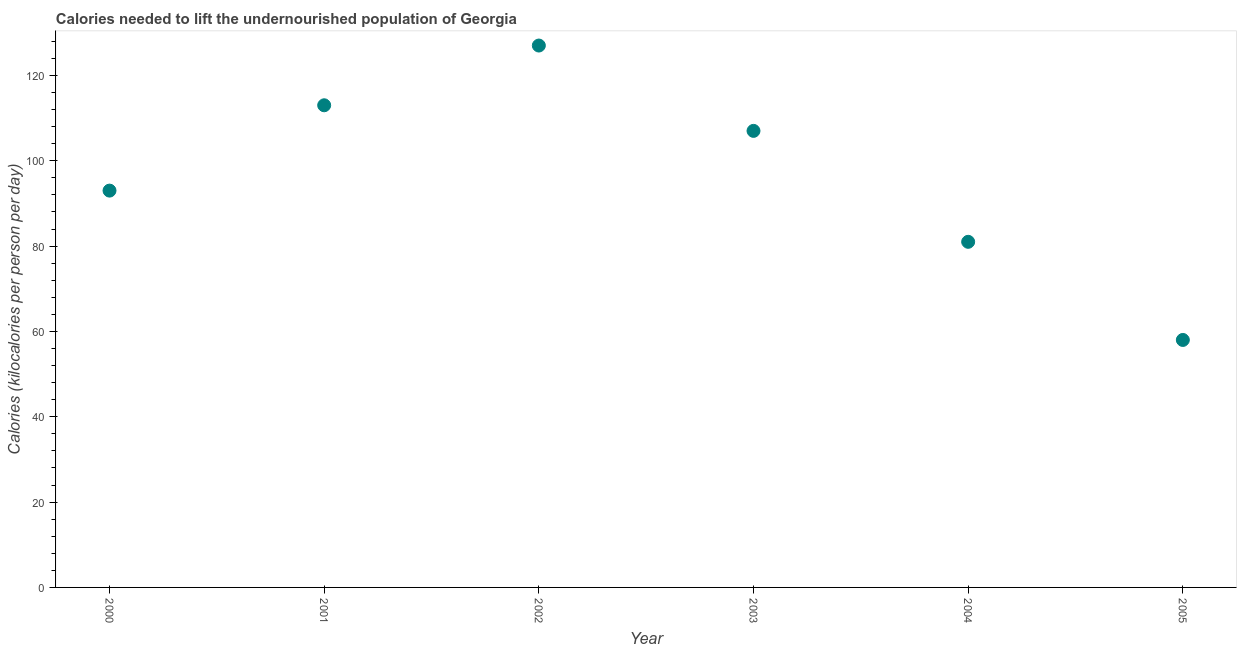What is the depth of food deficit in 2002?
Keep it short and to the point. 127. Across all years, what is the maximum depth of food deficit?
Offer a very short reply. 127. Across all years, what is the minimum depth of food deficit?
Your answer should be very brief. 58. What is the sum of the depth of food deficit?
Your response must be concise. 579. What is the difference between the depth of food deficit in 2000 and 2003?
Offer a very short reply. -14. What is the average depth of food deficit per year?
Your answer should be compact. 96.5. What is the median depth of food deficit?
Give a very brief answer. 100. What is the ratio of the depth of food deficit in 2004 to that in 2005?
Your answer should be very brief. 1.4. Is the difference between the depth of food deficit in 2000 and 2004 greater than the difference between any two years?
Offer a very short reply. No. Is the sum of the depth of food deficit in 2001 and 2004 greater than the maximum depth of food deficit across all years?
Ensure brevity in your answer.  Yes. What is the difference between the highest and the lowest depth of food deficit?
Provide a succinct answer. 69. Does the depth of food deficit monotonically increase over the years?
Your answer should be very brief. No. How many dotlines are there?
Your answer should be compact. 1. How many years are there in the graph?
Your answer should be compact. 6. What is the difference between two consecutive major ticks on the Y-axis?
Your answer should be compact. 20. Does the graph contain any zero values?
Keep it short and to the point. No. What is the title of the graph?
Ensure brevity in your answer.  Calories needed to lift the undernourished population of Georgia. What is the label or title of the Y-axis?
Offer a very short reply. Calories (kilocalories per person per day). What is the Calories (kilocalories per person per day) in 2000?
Ensure brevity in your answer.  93. What is the Calories (kilocalories per person per day) in 2001?
Your response must be concise. 113. What is the Calories (kilocalories per person per day) in 2002?
Offer a very short reply. 127. What is the Calories (kilocalories per person per day) in 2003?
Provide a short and direct response. 107. What is the difference between the Calories (kilocalories per person per day) in 2000 and 2001?
Ensure brevity in your answer.  -20. What is the difference between the Calories (kilocalories per person per day) in 2000 and 2002?
Make the answer very short. -34. What is the difference between the Calories (kilocalories per person per day) in 2001 and 2002?
Provide a short and direct response. -14. What is the difference between the Calories (kilocalories per person per day) in 2001 and 2005?
Keep it short and to the point. 55. What is the difference between the Calories (kilocalories per person per day) in 2002 and 2004?
Provide a short and direct response. 46. What is the difference between the Calories (kilocalories per person per day) in 2002 and 2005?
Ensure brevity in your answer.  69. What is the difference between the Calories (kilocalories per person per day) in 2003 and 2004?
Provide a short and direct response. 26. What is the difference between the Calories (kilocalories per person per day) in 2003 and 2005?
Give a very brief answer. 49. What is the ratio of the Calories (kilocalories per person per day) in 2000 to that in 2001?
Give a very brief answer. 0.82. What is the ratio of the Calories (kilocalories per person per day) in 2000 to that in 2002?
Provide a short and direct response. 0.73. What is the ratio of the Calories (kilocalories per person per day) in 2000 to that in 2003?
Make the answer very short. 0.87. What is the ratio of the Calories (kilocalories per person per day) in 2000 to that in 2004?
Make the answer very short. 1.15. What is the ratio of the Calories (kilocalories per person per day) in 2000 to that in 2005?
Make the answer very short. 1.6. What is the ratio of the Calories (kilocalories per person per day) in 2001 to that in 2002?
Your answer should be very brief. 0.89. What is the ratio of the Calories (kilocalories per person per day) in 2001 to that in 2003?
Offer a very short reply. 1.06. What is the ratio of the Calories (kilocalories per person per day) in 2001 to that in 2004?
Your response must be concise. 1.4. What is the ratio of the Calories (kilocalories per person per day) in 2001 to that in 2005?
Make the answer very short. 1.95. What is the ratio of the Calories (kilocalories per person per day) in 2002 to that in 2003?
Offer a very short reply. 1.19. What is the ratio of the Calories (kilocalories per person per day) in 2002 to that in 2004?
Your answer should be very brief. 1.57. What is the ratio of the Calories (kilocalories per person per day) in 2002 to that in 2005?
Keep it short and to the point. 2.19. What is the ratio of the Calories (kilocalories per person per day) in 2003 to that in 2004?
Make the answer very short. 1.32. What is the ratio of the Calories (kilocalories per person per day) in 2003 to that in 2005?
Offer a terse response. 1.84. What is the ratio of the Calories (kilocalories per person per day) in 2004 to that in 2005?
Your response must be concise. 1.4. 